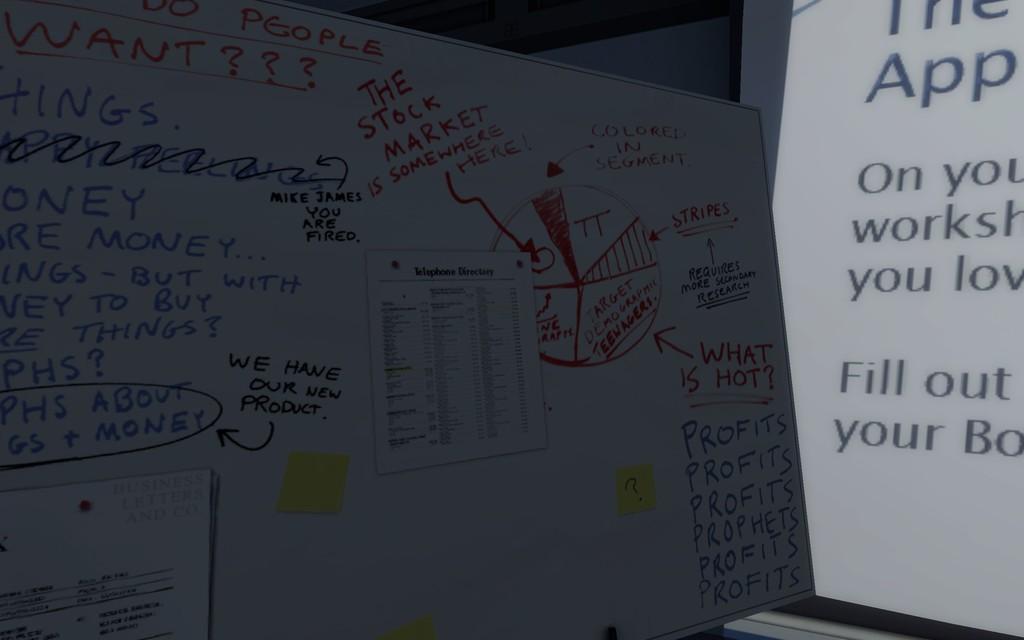What market is mentioned on the whiteboard written in red?
Ensure brevity in your answer.  Stock market. Whats the notes about?
Provide a short and direct response. The stock market. 